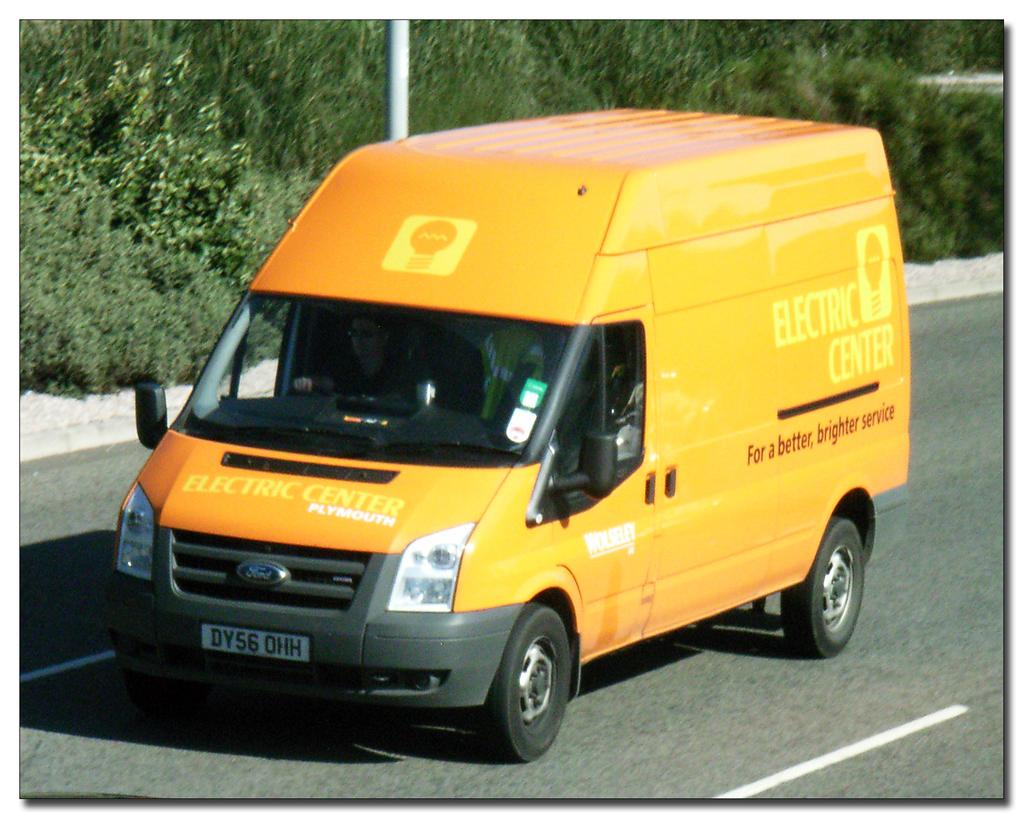What kind of service?
Your response must be concise. Better, brighter. What is written across the hood?
Keep it short and to the point. Electric center. 